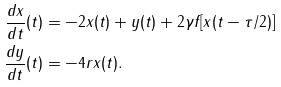Convert formula to latex. <formula><loc_0><loc_0><loc_500><loc_500>\frac { d x } { d t } ( t ) & = - 2 x ( t ) + y ( t ) + 2 \gamma f [ x ( t - \tau / 2 ) ] \\ \frac { d y } { d t } ( t ) & = - 4 r x ( t ) .</formula> 